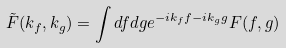<formula> <loc_0><loc_0><loc_500><loc_500>\tilde { F } ( k _ { f } , k _ { g } ) = \int d f d g e ^ { - i k _ { f } f - i k _ { g } g } F ( f , g )</formula> 